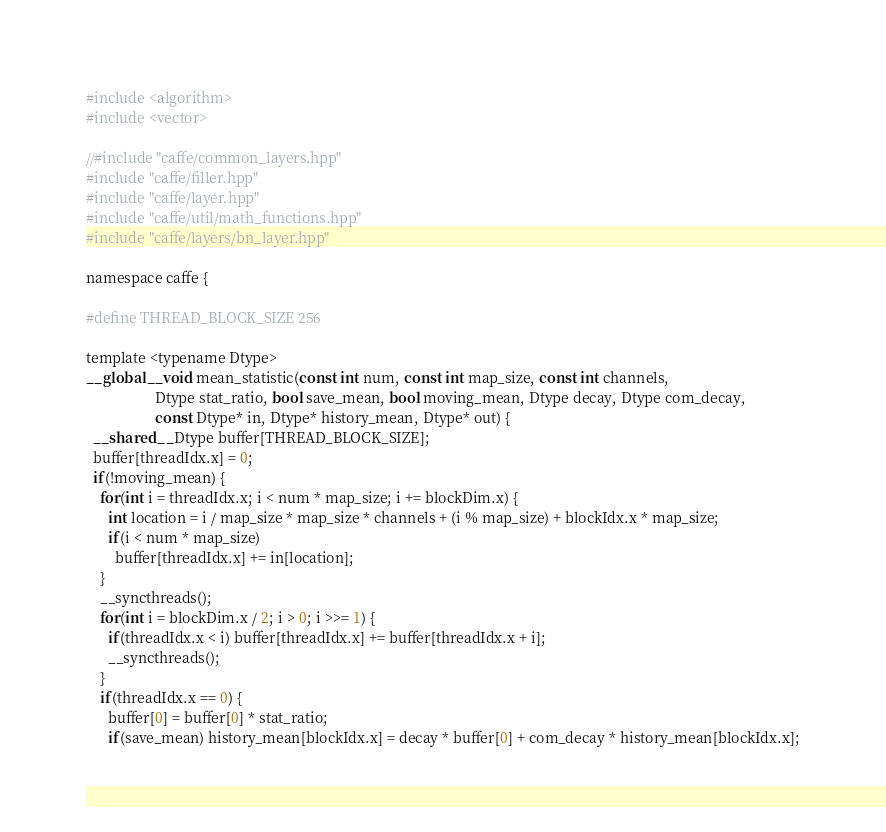Convert code to text. <code><loc_0><loc_0><loc_500><loc_500><_Cuda_>#include <algorithm>
#include <vector>

//#include "caffe/common_layers.hpp"
#include "caffe/filler.hpp"
#include "caffe/layer.hpp"
#include "caffe/util/math_functions.hpp"
#include "caffe/layers/bn_layer.hpp"

namespace caffe {

#define THREAD_BLOCK_SIZE 256

template <typename Dtype>
__global__ void mean_statistic(const int num, const int map_size, const int channels,
                   Dtype stat_ratio, bool save_mean, bool moving_mean, Dtype decay, Dtype com_decay,
                   const Dtype* in, Dtype* history_mean, Dtype* out) {
  __shared__ Dtype buffer[THREAD_BLOCK_SIZE];
  buffer[threadIdx.x] = 0;
  if(!moving_mean) {
    for(int i = threadIdx.x; i < num * map_size; i += blockDim.x) {
      int location = i / map_size * map_size * channels + (i % map_size) + blockIdx.x * map_size;
      if(i < num * map_size)
        buffer[threadIdx.x] += in[location];
    }
    __syncthreads();
    for(int i = blockDim.x / 2; i > 0; i >>= 1) {
      if(threadIdx.x < i) buffer[threadIdx.x] += buffer[threadIdx.x + i];
      __syncthreads();
    }
    if(threadIdx.x == 0) {
      buffer[0] = buffer[0] * stat_ratio;
      if(save_mean) history_mean[blockIdx.x] = decay * buffer[0] + com_decay * history_mean[blockIdx.x];</code> 